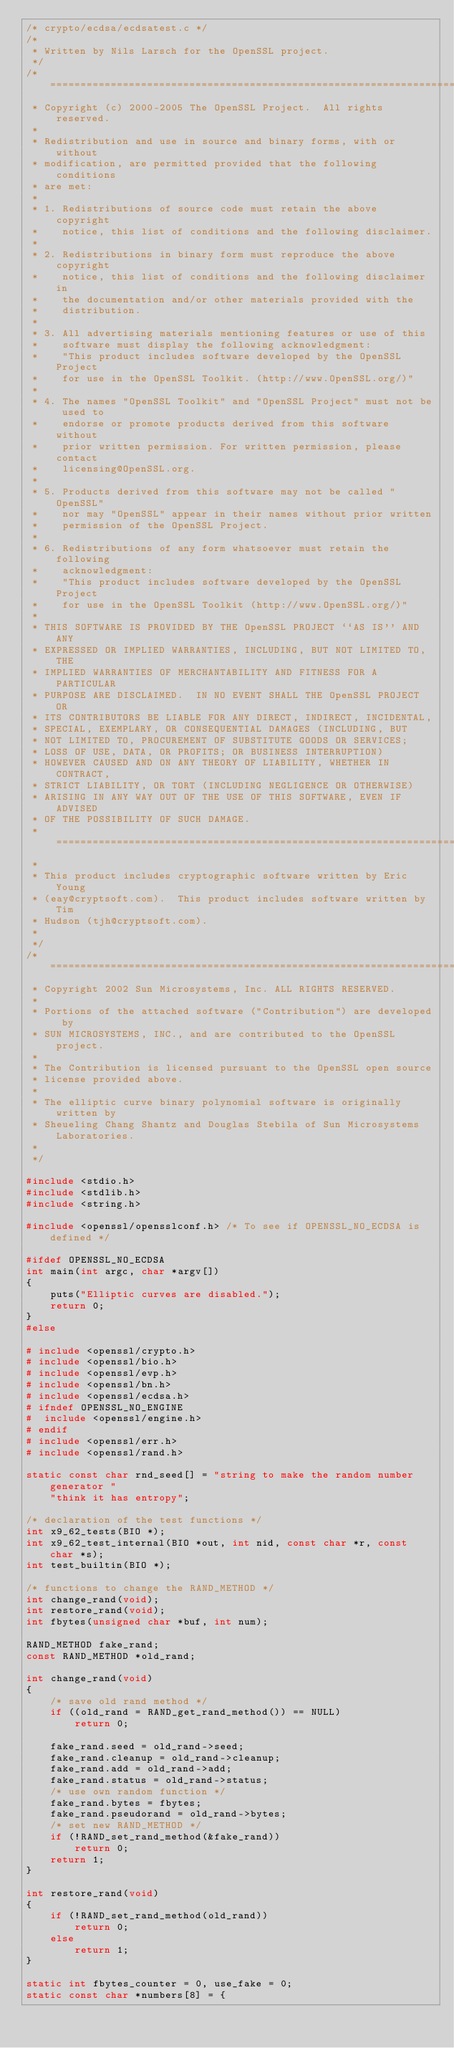Convert code to text. <code><loc_0><loc_0><loc_500><loc_500><_C_>/* crypto/ecdsa/ecdsatest.c */
/*
 * Written by Nils Larsch for the OpenSSL project.
 */
/* ====================================================================
 * Copyright (c) 2000-2005 The OpenSSL Project.  All rights reserved.
 *
 * Redistribution and use in source and binary forms, with or without
 * modification, are permitted provided that the following conditions
 * are met:
 *
 * 1. Redistributions of source code must retain the above copyright
 *    notice, this list of conditions and the following disclaimer.
 *
 * 2. Redistributions in binary form must reproduce the above copyright
 *    notice, this list of conditions and the following disclaimer in
 *    the documentation and/or other materials provided with the
 *    distribution.
 *
 * 3. All advertising materials mentioning features or use of this
 *    software must display the following acknowledgment:
 *    "This product includes software developed by the OpenSSL Project
 *    for use in the OpenSSL Toolkit. (http://www.OpenSSL.org/)"
 *
 * 4. The names "OpenSSL Toolkit" and "OpenSSL Project" must not be used to
 *    endorse or promote products derived from this software without
 *    prior written permission. For written permission, please contact
 *    licensing@OpenSSL.org.
 *
 * 5. Products derived from this software may not be called "OpenSSL"
 *    nor may "OpenSSL" appear in their names without prior written
 *    permission of the OpenSSL Project.
 *
 * 6. Redistributions of any form whatsoever must retain the following
 *    acknowledgment:
 *    "This product includes software developed by the OpenSSL Project
 *    for use in the OpenSSL Toolkit (http://www.OpenSSL.org/)"
 *
 * THIS SOFTWARE IS PROVIDED BY THE OpenSSL PROJECT ``AS IS'' AND ANY
 * EXPRESSED OR IMPLIED WARRANTIES, INCLUDING, BUT NOT LIMITED TO, THE
 * IMPLIED WARRANTIES OF MERCHANTABILITY AND FITNESS FOR A PARTICULAR
 * PURPOSE ARE DISCLAIMED.  IN NO EVENT SHALL THE OpenSSL PROJECT OR
 * ITS CONTRIBUTORS BE LIABLE FOR ANY DIRECT, INDIRECT, INCIDENTAL,
 * SPECIAL, EXEMPLARY, OR CONSEQUENTIAL DAMAGES (INCLUDING, BUT
 * NOT LIMITED TO, PROCUREMENT OF SUBSTITUTE GOODS OR SERVICES;
 * LOSS OF USE, DATA, OR PROFITS; OR BUSINESS INTERRUPTION)
 * HOWEVER CAUSED AND ON ANY THEORY OF LIABILITY, WHETHER IN CONTRACT,
 * STRICT LIABILITY, OR TORT (INCLUDING NEGLIGENCE OR OTHERWISE)
 * ARISING IN ANY WAY OUT OF THE USE OF THIS SOFTWARE, EVEN IF ADVISED
 * OF THE POSSIBILITY OF SUCH DAMAGE.
 * ====================================================================
 *
 * This product includes cryptographic software written by Eric Young
 * (eay@cryptsoft.com).  This product includes software written by Tim
 * Hudson (tjh@cryptsoft.com).
 *
 */
/* ====================================================================
 * Copyright 2002 Sun Microsystems, Inc. ALL RIGHTS RESERVED.
 *
 * Portions of the attached software ("Contribution") are developed by
 * SUN MICROSYSTEMS, INC., and are contributed to the OpenSSL project.
 *
 * The Contribution is licensed pursuant to the OpenSSL open source
 * license provided above.
 *
 * The elliptic curve binary polynomial software is originally written by
 * Sheueling Chang Shantz and Douglas Stebila of Sun Microsystems Laboratories.
 *
 */

#include <stdio.h>
#include <stdlib.h>
#include <string.h>

#include <openssl/opensslconf.h> /* To see if OPENSSL_NO_ECDSA is defined */

#ifdef OPENSSL_NO_ECDSA
int main(int argc, char *argv[])
{
    puts("Elliptic curves are disabled.");
    return 0;
}
#else

# include <openssl/crypto.h>
# include <openssl/bio.h>
# include <openssl/evp.h>
# include <openssl/bn.h>
# include <openssl/ecdsa.h>
# ifndef OPENSSL_NO_ENGINE
#  include <openssl/engine.h>
# endif
# include <openssl/err.h>
# include <openssl/rand.h>

static const char rnd_seed[] = "string to make the random number generator "
    "think it has entropy";

/* declaration of the test functions */
int x9_62_tests(BIO *);
int x9_62_test_internal(BIO *out, int nid, const char *r, const char *s);
int test_builtin(BIO *);

/* functions to change the RAND_METHOD */
int change_rand(void);
int restore_rand(void);
int fbytes(unsigned char *buf, int num);

RAND_METHOD fake_rand;
const RAND_METHOD *old_rand;

int change_rand(void)
{
    /* save old rand method */
    if ((old_rand = RAND_get_rand_method()) == NULL)
        return 0;

    fake_rand.seed = old_rand->seed;
    fake_rand.cleanup = old_rand->cleanup;
    fake_rand.add = old_rand->add;
    fake_rand.status = old_rand->status;
    /* use own random function */
    fake_rand.bytes = fbytes;
    fake_rand.pseudorand = old_rand->bytes;
    /* set new RAND_METHOD */
    if (!RAND_set_rand_method(&fake_rand))
        return 0;
    return 1;
}

int restore_rand(void)
{
    if (!RAND_set_rand_method(old_rand))
        return 0;
    else
        return 1;
}

static int fbytes_counter = 0, use_fake = 0;
static const char *numbers[8] = {</code> 